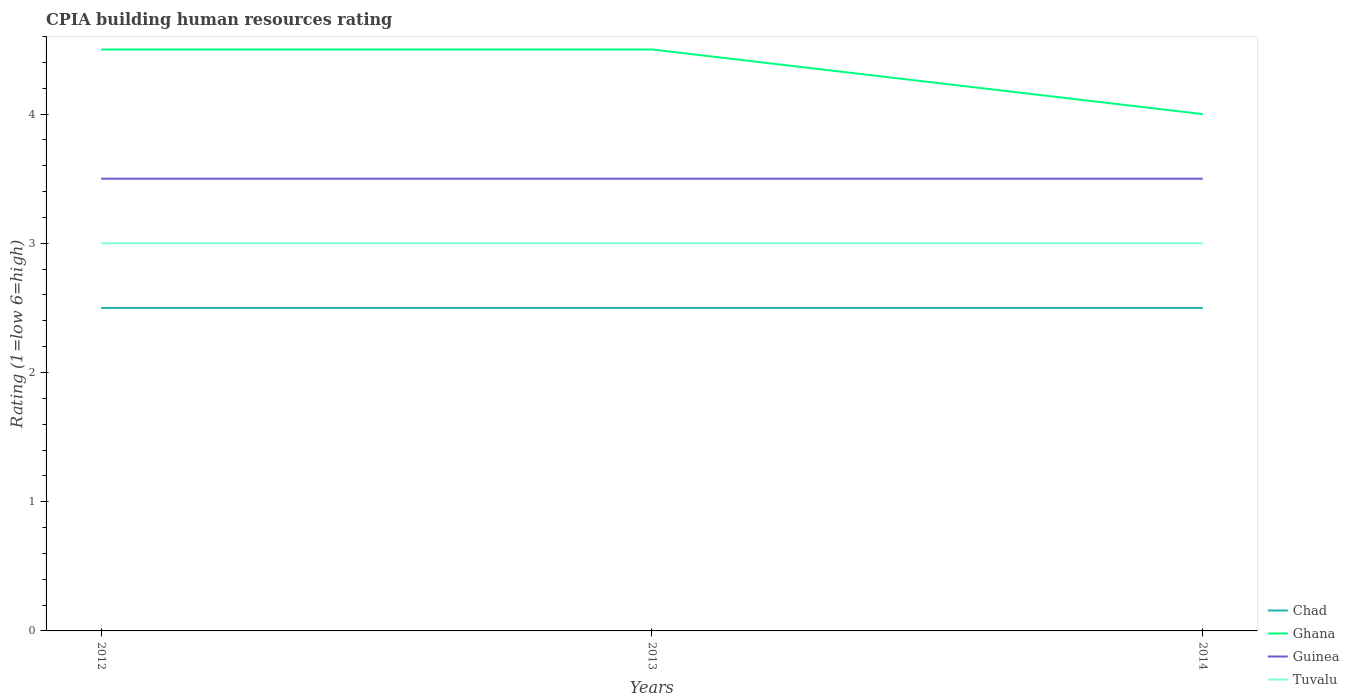Across all years, what is the maximum CPIA rating in Guinea?
Your response must be concise. 3.5. What is the total CPIA rating in Ghana in the graph?
Keep it short and to the point. 0. What is the difference between the highest and the second highest CPIA rating in Guinea?
Offer a very short reply. 0. Is the CPIA rating in Tuvalu strictly greater than the CPIA rating in Ghana over the years?
Your answer should be very brief. Yes. How many lines are there?
Keep it short and to the point. 4. How many years are there in the graph?
Provide a short and direct response. 3. Does the graph contain grids?
Give a very brief answer. No. How are the legend labels stacked?
Keep it short and to the point. Vertical. What is the title of the graph?
Your response must be concise. CPIA building human resources rating. Does "Guatemala" appear as one of the legend labels in the graph?
Make the answer very short. No. What is the Rating (1=low 6=high) in Chad in 2012?
Offer a very short reply. 2.5. What is the Rating (1=low 6=high) of Ghana in 2012?
Ensure brevity in your answer.  4.5. What is the Rating (1=low 6=high) in Guinea in 2012?
Ensure brevity in your answer.  3.5. What is the Rating (1=low 6=high) of Tuvalu in 2012?
Keep it short and to the point. 3. What is the Rating (1=low 6=high) of Chad in 2013?
Your answer should be very brief. 2.5. What is the Rating (1=low 6=high) in Ghana in 2013?
Provide a short and direct response. 4.5. What is the Rating (1=low 6=high) of Guinea in 2013?
Provide a short and direct response. 3.5. What is the Rating (1=low 6=high) of Chad in 2014?
Offer a terse response. 2.5. What is the Rating (1=low 6=high) in Guinea in 2014?
Your answer should be compact. 3.5. Across all years, what is the maximum Rating (1=low 6=high) in Chad?
Offer a terse response. 2.5. Across all years, what is the maximum Rating (1=low 6=high) in Guinea?
Offer a terse response. 3.5. Across all years, what is the maximum Rating (1=low 6=high) of Tuvalu?
Provide a short and direct response. 3. Across all years, what is the minimum Rating (1=low 6=high) in Chad?
Keep it short and to the point. 2.5. Across all years, what is the minimum Rating (1=low 6=high) in Ghana?
Provide a succinct answer. 4. Across all years, what is the minimum Rating (1=low 6=high) in Tuvalu?
Your answer should be very brief. 3. What is the total Rating (1=low 6=high) in Chad in the graph?
Provide a succinct answer. 7.5. What is the total Rating (1=low 6=high) in Ghana in the graph?
Your answer should be very brief. 13. What is the difference between the Rating (1=low 6=high) in Chad in 2012 and that in 2013?
Ensure brevity in your answer.  0. What is the difference between the Rating (1=low 6=high) of Guinea in 2012 and that in 2013?
Your response must be concise. 0. What is the difference between the Rating (1=low 6=high) in Tuvalu in 2012 and that in 2013?
Your response must be concise. 0. What is the difference between the Rating (1=low 6=high) of Ghana in 2012 and that in 2014?
Keep it short and to the point. 0.5. What is the difference between the Rating (1=low 6=high) in Tuvalu in 2012 and that in 2014?
Make the answer very short. 0. What is the difference between the Rating (1=low 6=high) of Tuvalu in 2013 and that in 2014?
Keep it short and to the point. 0. What is the difference between the Rating (1=low 6=high) in Chad in 2012 and the Rating (1=low 6=high) in Ghana in 2013?
Your answer should be very brief. -2. What is the difference between the Rating (1=low 6=high) in Chad in 2012 and the Rating (1=low 6=high) in Guinea in 2013?
Your response must be concise. -1. What is the difference between the Rating (1=low 6=high) of Chad in 2012 and the Rating (1=low 6=high) of Tuvalu in 2013?
Keep it short and to the point. -0.5. What is the difference between the Rating (1=low 6=high) of Ghana in 2012 and the Rating (1=low 6=high) of Guinea in 2013?
Make the answer very short. 1. What is the difference between the Rating (1=low 6=high) of Ghana in 2012 and the Rating (1=low 6=high) of Tuvalu in 2013?
Make the answer very short. 1.5. What is the difference between the Rating (1=low 6=high) in Guinea in 2012 and the Rating (1=low 6=high) in Tuvalu in 2013?
Your response must be concise. 0.5. What is the difference between the Rating (1=low 6=high) of Chad in 2012 and the Rating (1=low 6=high) of Ghana in 2014?
Your answer should be compact. -1.5. What is the difference between the Rating (1=low 6=high) of Chad in 2012 and the Rating (1=low 6=high) of Guinea in 2014?
Offer a terse response. -1. What is the difference between the Rating (1=low 6=high) in Ghana in 2012 and the Rating (1=low 6=high) in Tuvalu in 2014?
Your answer should be compact. 1.5. What is the difference between the Rating (1=low 6=high) of Chad in 2013 and the Rating (1=low 6=high) of Guinea in 2014?
Provide a short and direct response. -1. What is the difference between the Rating (1=low 6=high) in Chad in 2013 and the Rating (1=low 6=high) in Tuvalu in 2014?
Your answer should be very brief. -0.5. What is the difference between the Rating (1=low 6=high) of Ghana in 2013 and the Rating (1=low 6=high) of Guinea in 2014?
Ensure brevity in your answer.  1. What is the difference between the Rating (1=low 6=high) of Guinea in 2013 and the Rating (1=low 6=high) of Tuvalu in 2014?
Give a very brief answer. 0.5. What is the average Rating (1=low 6=high) of Ghana per year?
Your answer should be very brief. 4.33. In the year 2012, what is the difference between the Rating (1=low 6=high) of Chad and Rating (1=low 6=high) of Ghana?
Offer a very short reply. -2. In the year 2013, what is the difference between the Rating (1=low 6=high) in Ghana and Rating (1=low 6=high) in Guinea?
Ensure brevity in your answer.  1. In the year 2013, what is the difference between the Rating (1=low 6=high) of Guinea and Rating (1=low 6=high) of Tuvalu?
Provide a succinct answer. 0.5. In the year 2014, what is the difference between the Rating (1=low 6=high) in Ghana and Rating (1=low 6=high) in Guinea?
Offer a very short reply. 0.5. In the year 2014, what is the difference between the Rating (1=low 6=high) in Ghana and Rating (1=low 6=high) in Tuvalu?
Keep it short and to the point. 1. What is the ratio of the Rating (1=low 6=high) of Chad in 2012 to that in 2013?
Offer a very short reply. 1. What is the ratio of the Rating (1=low 6=high) in Guinea in 2012 to that in 2013?
Keep it short and to the point. 1. What is the ratio of the Rating (1=low 6=high) in Chad in 2012 to that in 2014?
Keep it short and to the point. 1. What is the ratio of the Rating (1=low 6=high) of Ghana in 2012 to that in 2014?
Offer a terse response. 1.12. What is the ratio of the Rating (1=low 6=high) of Guinea in 2012 to that in 2014?
Your answer should be compact. 1. What is the ratio of the Rating (1=low 6=high) in Tuvalu in 2012 to that in 2014?
Your answer should be compact. 1. What is the ratio of the Rating (1=low 6=high) in Chad in 2013 to that in 2014?
Your answer should be very brief. 1. What is the ratio of the Rating (1=low 6=high) of Ghana in 2013 to that in 2014?
Provide a short and direct response. 1.12. What is the ratio of the Rating (1=low 6=high) of Guinea in 2013 to that in 2014?
Offer a terse response. 1. What is the ratio of the Rating (1=low 6=high) of Tuvalu in 2013 to that in 2014?
Your response must be concise. 1. What is the difference between the highest and the second highest Rating (1=low 6=high) of Chad?
Keep it short and to the point. 0. What is the difference between the highest and the second highest Rating (1=low 6=high) in Guinea?
Offer a terse response. 0. What is the difference between the highest and the second highest Rating (1=low 6=high) in Tuvalu?
Your response must be concise. 0. What is the difference between the highest and the lowest Rating (1=low 6=high) of Ghana?
Provide a succinct answer. 0.5. 